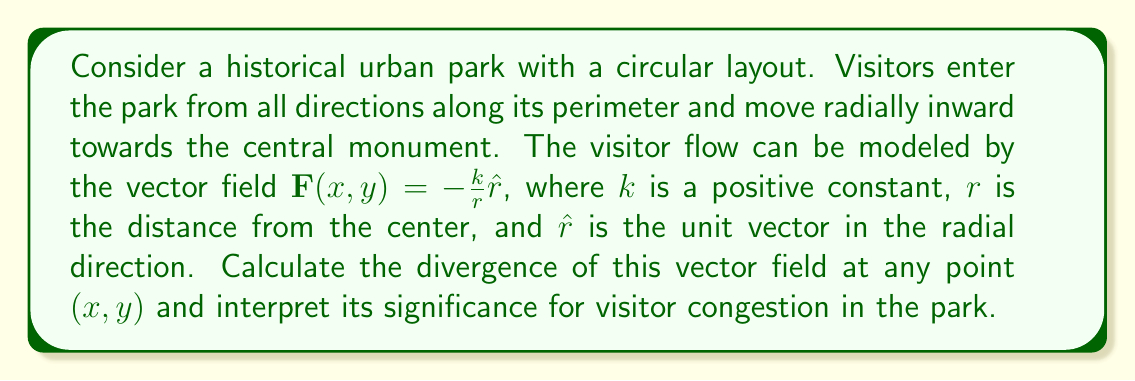Can you answer this question? 1) First, we need to express the vector field in Cartesian coordinates:
   $\mathbf{F}(x,y) = -\frac{k}{r}(\frac{x}{r}\hat{i} + \frac{y}{r}\hat{j})$
   where $r = \sqrt{x^2 + y^2}$

2) The divergence in Cartesian coordinates is given by:
   $\nabla \cdot \mathbf{F} = \frac{\partial F_x}{\partial x} + \frac{\partial F_y}{\partial y}$

3) Calculate $\frac{\partial F_x}{\partial x}$:
   $F_x = -\frac{kx}{r^2} = -\frac{kx}{(x^2+y^2)}$
   $\frac{\partial F_x}{\partial x} = -k\frac{(x^2+y^2) - 2x^2}{(x^2+y^2)^2} = -k\frac{y^2-x^2}{(x^2+y^2)^2}$

4) Calculate $\frac{\partial F_y}{\partial y}$:
   $F_y = -\frac{ky}{r^2} = -\frac{ky}{(x^2+y^2)}$
   $\frac{\partial F_y}{\partial y} = -k\frac{(x^2+y^2) - 2y^2}{(x^2+y^2)^2} = -k\frac{x^2-y^2}{(x^2+y^2)^2}$

5) Sum the partial derivatives:
   $\nabla \cdot \mathbf{F} = -k\frac{y^2-x^2}{(x^2+y^2)^2} - k\frac{x^2-y^2}{(x^2+y^2)^2} = -\frac{2k}{x^2+y^2} = -\frac{2k}{r^2}$

6) Interpretation: The negative divergence indicates that visitors are converging towards the center of the park. The magnitude of convergence increases as $r$ decreases, suggesting higher congestion closer to the central monument.
Answer: $-\frac{2k}{r^2}$ 